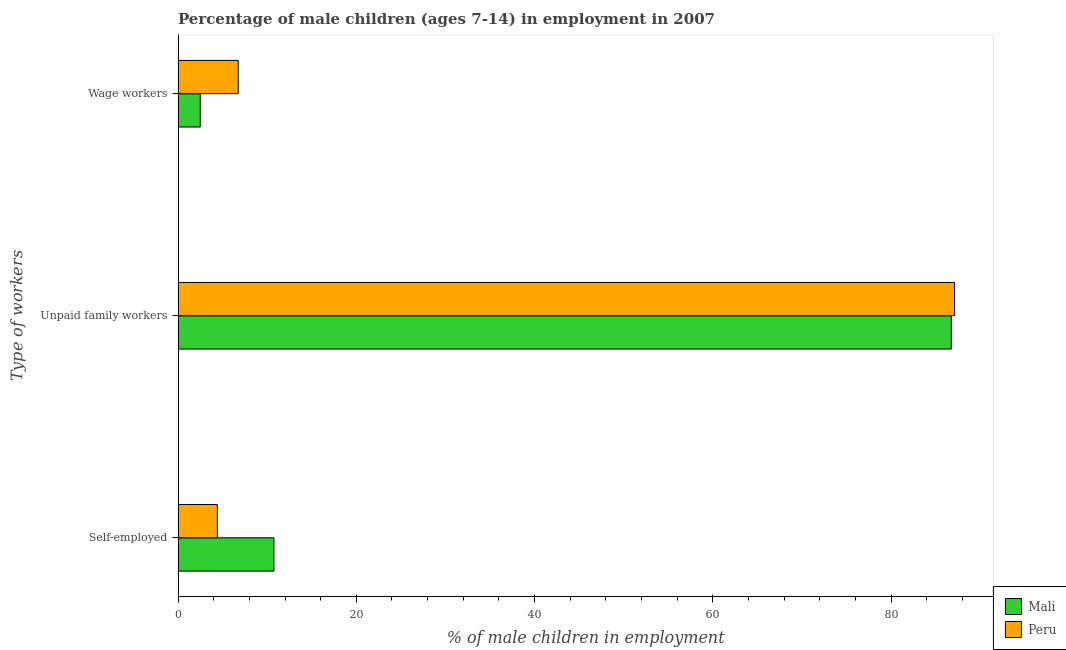How many bars are there on the 2nd tick from the top?
Your answer should be very brief. 2. What is the label of the 2nd group of bars from the top?
Make the answer very short. Unpaid family workers. What is the percentage of children employed as unpaid family workers in Mali?
Your answer should be very brief. 86.76. Across all countries, what is the maximum percentage of children employed as unpaid family workers?
Keep it short and to the point. 87.13. Across all countries, what is the minimum percentage of children employed as unpaid family workers?
Offer a terse response. 86.76. In which country was the percentage of self employed children maximum?
Make the answer very short. Mali. What is the total percentage of children employed as wage workers in the graph?
Your response must be concise. 9.24. What is the difference between the percentage of self employed children in Peru and that in Mali?
Your answer should be very brief. -6.35. What is the difference between the percentage of children employed as unpaid family workers in Mali and the percentage of children employed as wage workers in Peru?
Offer a very short reply. 80.01. What is the average percentage of children employed as unpaid family workers per country?
Give a very brief answer. 86.94. What is the difference between the percentage of self employed children and percentage of children employed as unpaid family workers in Mali?
Provide a short and direct response. -76. In how many countries, is the percentage of self employed children greater than 48 %?
Offer a terse response. 0. What is the ratio of the percentage of children employed as wage workers in Mali to that in Peru?
Offer a terse response. 0.37. Is the percentage of self employed children in Mali less than that in Peru?
Keep it short and to the point. No. What is the difference between the highest and the second highest percentage of self employed children?
Provide a short and direct response. 6.35. What is the difference between the highest and the lowest percentage of self employed children?
Your answer should be compact. 6.35. What does the 2nd bar from the top in Self-employed represents?
Provide a short and direct response. Mali. What does the 2nd bar from the bottom in Wage workers represents?
Make the answer very short. Peru. How many countries are there in the graph?
Keep it short and to the point. 2. What is the difference between two consecutive major ticks on the X-axis?
Keep it short and to the point. 20. Does the graph contain grids?
Give a very brief answer. No. What is the title of the graph?
Make the answer very short. Percentage of male children (ages 7-14) in employment in 2007. What is the label or title of the X-axis?
Keep it short and to the point. % of male children in employment. What is the label or title of the Y-axis?
Offer a very short reply. Type of workers. What is the % of male children in employment in Mali in Self-employed?
Your response must be concise. 10.76. What is the % of male children in employment in Peru in Self-employed?
Make the answer very short. 4.41. What is the % of male children in employment in Mali in Unpaid family workers?
Make the answer very short. 86.76. What is the % of male children in employment in Peru in Unpaid family workers?
Your response must be concise. 87.13. What is the % of male children in employment of Mali in Wage workers?
Provide a short and direct response. 2.49. What is the % of male children in employment of Peru in Wage workers?
Provide a succinct answer. 6.75. Across all Type of workers, what is the maximum % of male children in employment of Mali?
Provide a succinct answer. 86.76. Across all Type of workers, what is the maximum % of male children in employment of Peru?
Ensure brevity in your answer.  87.13. Across all Type of workers, what is the minimum % of male children in employment in Mali?
Make the answer very short. 2.49. Across all Type of workers, what is the minimum % of male children in employment of Peru?
Your answer should be very brief. 4.41. What is the total % of male children in employment of Mali in the graph?
Make the answer very short. 100.01. What is the total % of male children in employment of Peru in the graph?
Your response must be concise. 98.29. What is the difference between the % of male children in employment of Mali in Self-employed and that in Unpaid family workers?
Provide a succinct answer. -76. What is the difference between the % of male children in employment in Peru in Self-employed and that in Unpaid family workers?
Provide a succinct answer. -82.72. What is the difference between the % of male children in employment of Mali in Self-employed and that in Wage workers?
Make the answer very short. 8.27. What is the difference between the % of male children in employment in Peru in Self-employed and that in Wage workers?
Make the answer very short. -2.34. What is the difference between the % of male children in employment in Mali in Unpaid family workers and that in Wage workers?
Keep it short and to the point. 84.27. What is the difference between the % of male children in employment of Peru in Unpaid family workers and that in Wage workers?
Your answer should be compact. 80.38. What is the difference between the % of male children in employment in Mali in Self-employed and the % of male children in employment in Peru in Unpaid family workers?
Offer a very short reply. -76.37. What is the difference between the % of male children in employment of Mali in Self-employed and the % of male children in employment of Peru in Wage workers?
Give a very brief answer. 4.01. What is the difference between the % of male children in employment in Mali in Unpaid family workers and the % of male children in employment in Peru in Wage workers?
Your answer should be very brief. 80.01. What is the average % of male children in employment of Mali per Type of workers?
Provide a succinct answer. 33.34. What is the average % of male children in employment of Peru per Type of workers?
Ensure brevity in your answer.  32.76. What is the difference between the % of male children in employment in Mali and % of male children in employment in Peru in Self-employed?
Keep it short and to the point. 6.35. What is the difference between the % of male children in employment in Mali and % of male children in employment in Peru in Unpaid family workers?
Your response must be concise. -0.37. What is the difference between the % of male children in employment in Mali and % of male children in employment in Peru in Wage workers?
Give a very brief answer. -4.26. What is the ratio of the % of male children in employment in Mali in Self-employed to that in Unpaid family workers?
Offer a terse response. 0.12. What is the ratio of the % of male children in employment in Peru in Self-employed to that in Unpaid family workers?
Offer a terse response. 0.05. What is the ratio of the % of male children in employment of Mali in Self-employed to that in Wage workers?
Ensure brevity in your answer.  4.32. What is the ratio of the % of male children in employment of Peru in Self-employed to that in Wage workers?
Provide a short and direct response. 0.65. What is the ratio of the % of male children in employment in Mali in Unpaid family workers to that in Wage workers?
Ensure brevity in your answer.  34.84. What is the ratio of the % of male children in employment of Peru in Unpaid family workers to that in Wage workers?
Your answer should be very brief. 12.91. What is the difference between the highest and the second highest % of male children in employment of Peru?
Provide a short and direct response. 80.38. What is the difference between the highest and the lowest % of male children in employment in Mali?
Make the answer very short. 84.27. What is the difference between the highest and the lowest % of male children in employment in Peru?
Your answer should be very brief. 82.72. 